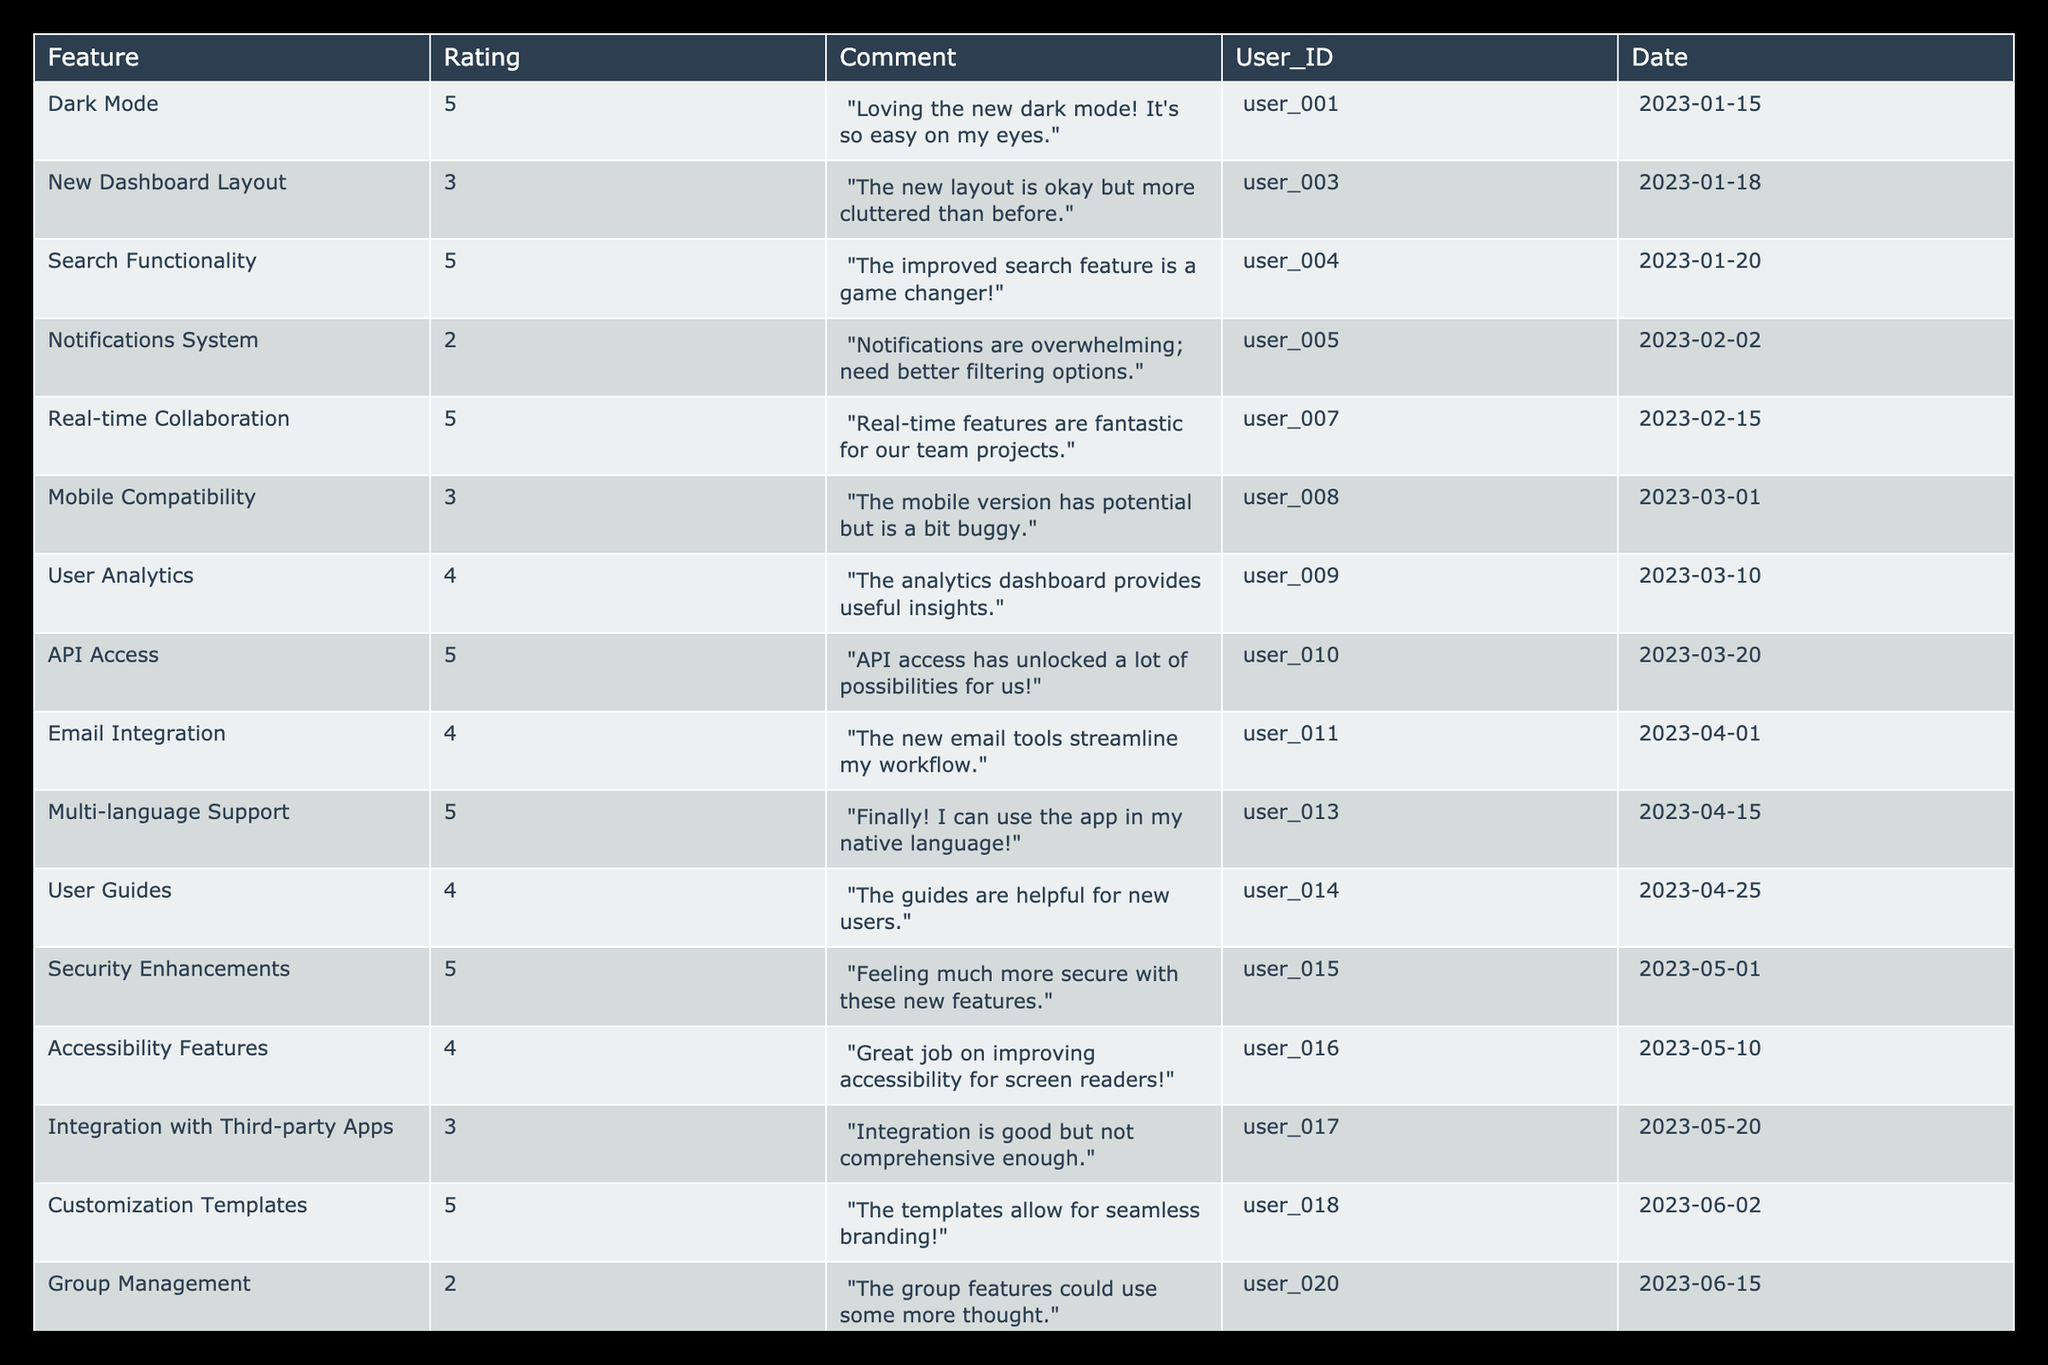What is the highest rating given to a feature in 2023? The table shows various features along with their ratings. Scanning the Rating column, the highest score is 5, which is given to multiple features including Dark Mode, Search Functionality, Real-time Collaboration, API Access, Multi-language Support, Customization Templates, Payment Gateways, Enhanced Search Filters.
Answer: 5 Which feature received a rating of 2? Looking through the Rating column, the feature Group Management is the only one that received a rating of 2.
Answer: Group Management What is the average rating of all the features listed? To find the average, the total of all ratings needs to be calculated. The ratings are 5, 3, 5, 2, 5, 3, 4, 5, 4, 5, 4, 5, 4, 3, 5, 2, 5, 4, 5. This sums to 71. There are 19 ratings, so the average is 71 divided by 19, which is approximately 3.74.
Answer: 3.74 Did any feature receive more than one five-star rating? By examining the table, several features show a rating of 5. These include Dark Mode, Search Functionality, Real-time Collaboration, API Access, Multi-language Support, Customization Templates, Payment Gateways, Enhanced Search Filters. Therefore, yes, multiple features received five-star ratings.
Answer: Yes Which user provided feedback for the Mobile Compatibility feature? The table indicates Mobile Compatibility has a corresponding User_ID. Looking up this feature shows that user_008 provided feedback for it.
Answer: user_008 What is the percentage of features that received a 4 rating or higher? First, count the total number of features: there are 19 total. Now count how many received a 4 or higher: these are 11 features (Dark Mode, Search Functionality, Real-time Collaboration, API Access, Multi-language Support, User Guides, Security Enhancements, Accessibility Features, Payment Gateways, Better Support Channels, Enhanced Search Filters). The percentage is 11 divided by 19, multiplied by 100, which gives approximately 57.89%.
Answer: 57.89% Which feature had the most recent user feedback date? Scanning the Date column in descending order, Enhanced Search Filters has the latest date, which is 2023-08-01.
Answer: Enhanced Search Filters Did any user leave a comment about the Notifications System? Checking the table for comments related to the Notifications System, user_005 provided feedback, indicating that someone did indeed comment on it.
Answer: Yes How many unique users provided feedback on features with a rating of 5? By looking at the User_IDs associated with features rated at 5 (Dark Mode, Search Functionality, Real-time Collaboration, API Access, Multi-language Support, Customization Templates, Payment Gateways, Enhanced Search Filters), the unique User_IDs are user_001, user_004, user_007, user_010, user_013, user_018, user_021, user_024, totaling 8 unique users providing feedback.
Answer: 8 